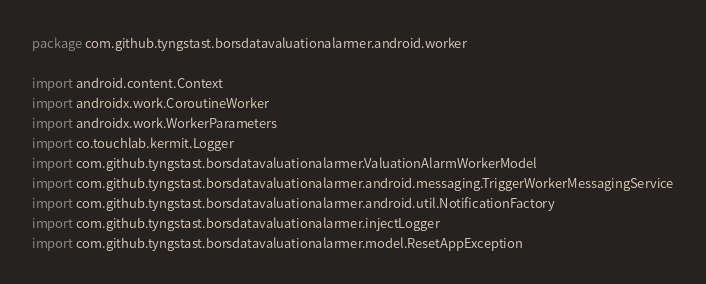Convert code to text. <code><loc_0><loc_0><loc_500><loc_500><_Kotlin_>package com.github.tyngstast.borsdatavaluationalarmer.android.worker

import android.content.Context
import androidx.work.CoroutineWorker
import androidx.work.WorkerParameters
import co.touchlab.kermit.Logger
import com.github.tyngstast.borsdatavaluationalarmer.ValuationAlarmWorkerModel
import com.github.tyngstast.borsdatavaluationalarmer.android.messaging.TriggerWorkerMessagingService
import com.github.tyngstast.borsdatavaluationalarmer.android.util.NotificationFactory
import com.github.tyngstast.borsdatavaluationalarmer.injectLogger
import com.github.tyngstast.borsdatavaluationalarmer.model.ResetAppException</code> 